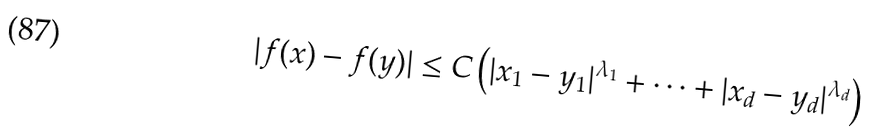Convert formula to latex. <formula><loc_0><loc_0><loc_500><loc_500>| f ( x ) - f ( y ) | \leq C \left ( | x _ { 1 } - y _ { 1 } | ^ { \lambda _ { 1 } } + \cdots + | x _ { d } - y _ { d } | ^ { \lambda _ { d } } \right )</formula> 